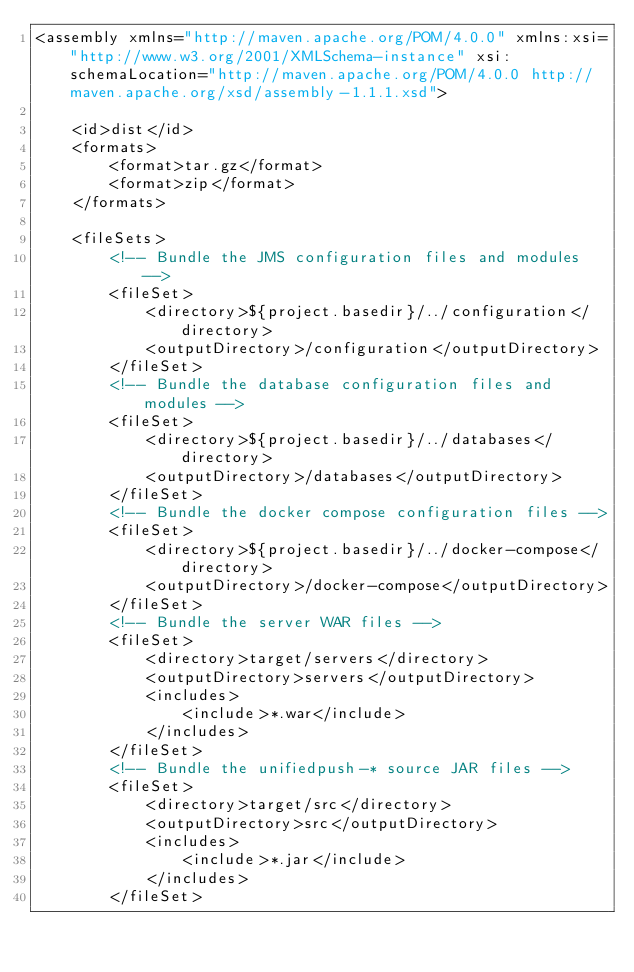Convert code to text. <code><loc_0><loc_0><loc_500><loc_500><_XML_><assembly xmlns="http://maven.apache.org/POM/4.0.0" xmlns:xsi="http://www.w3.org/2001/XMLSchema-instance" xsi:schemaLocation="http://maven.apache.org/POM/4.0.0 http://maven.apache.org/xsd/assembly-1.1.1.xsd">

    <id>dist</id>
    <formats>
        <format>tar.gz</format>
        <format>zip</format>
    </formats>
    
    <fileSets>
        <!-- Bundle the JMS configuration files and modules -->
        <fileSet>
            <directory>${project.basedir}/../configuration</directory>
            <outputDirectory>/configuration</outputDirectory>
        </fileSet>
        <!-- Bundle the database configuration files and modules -->
        <fileSet>
            <directory>${project.basedir}/../databases</directory>
            <outputDirectory>/databases</outputDirectory>
        </fileSet>
        <!-- Bundle the docker compose configuration files -->
        <fileSet>
            <directory>${project.basedir}/../docker-compose</directory>
            <outputDirectory>/docker-compose</outputDirectory>
        </fileSet>
        <!-- Bundle the server WAR files -->
        <fileSet>
            <directory>target/servers</directory>
            <outputDirectory>servers</outputDirectory>
            <includes>
                <include>*.war</include>
            </includes>
        </fileSet>
        <!-- Bundle the unifiedpush-* source JAR files --> 
        <fileSet>
            <directory>target/src</directory>
            <outputDirectory>src</outputDirectory>
            <includes>
                <include>*.jar</include>
            </includes>
        </fileSet></code> 